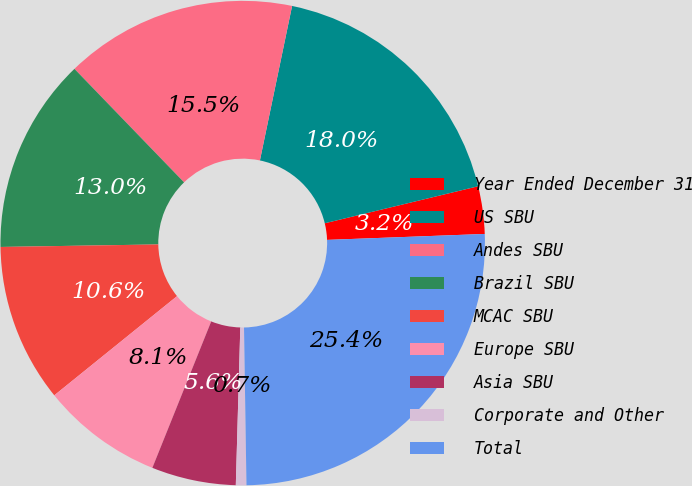<chart> <loc_0><loc_0><loc_500><loc_500><pie_chart><fcel>Year Ended December 31<fcel>US SBU<fcel>Andes SBU<fcel>Brazil SBU<fcel>MCAC SBU<fcel>Europe SBU<fcel>Asia SBU<fcel>Corporate and Other<fcel>Total<nl><fcel>3.17%<fcel>17.96%<fcel>15.49%<fcel>13.03%<fcel>10.56%<fcel>8.1%<fcel>5.63%<fcel>0.7%<fcel>25.35%<nl></chart> 